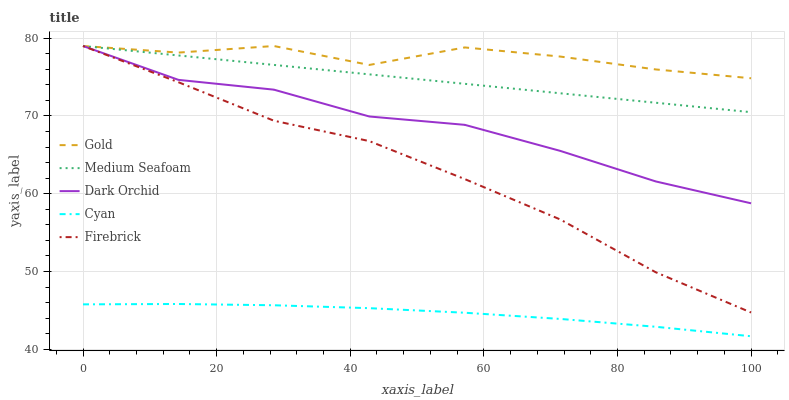Does Cyan have the minimum area under the curve?
Answer yes or no. Yes. Does Gold have the maximum area under the curve?
Answer yes or no. Yes. Does Firebrick have the minimum area under the curve?
Answer yes or no. No. Does Firebrick have the maximum area under the curve?
Answer yes or no. No. Is Medium Seafoam the smoothest?
Answer yes or no. Yes. Is Gold the roughest?
Answer yes or no. Yes. Is Cyan the smoothest?
Answer yes or no. No. Is Cyan the roughest?
Answer yes or no. No. Does Cyan have the lowest value?
Answer yes or no. Yes. Does Firebrick have the lowest value?
Answer yes or no. No. Does Gold have the highest value?
Answer yes or no. Yes. Does Cyan have the highest value?
Answer yes or no. No. Is Cyan less than Firebrick?
Answer yes or no. Yes. Is Gold greater than Cyan?
Answer yes or no. Yes. Does Dark Orchid intersect Medium Seafoam?
Answer yes or no. Yes. Is Dark Orchid less than Medium Seafoam?
Answer yes or no. No. Is Dark Orchid greater than Medium Seafoam?
Answer yes or no. No. Does Cyan intersect Firebrick?
Answer yes or no. No. 